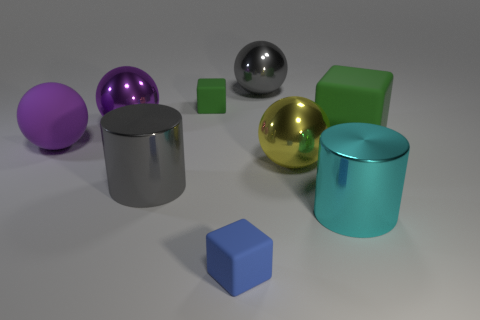The metal ball that is the same color as the rubber ball is what size?
Make the answer very short. Large. Does the large rubber object that is on the right side of the gray sphere have the same color as the tiny rubber block behind the gray metal cylinder?
Your response must be concise. Yes. There is a big thing that is the same color as the big matte ball; what shape is it?
Provide a succinct answer. Sphere. Is there any other thing that is the same color as the large rubber block?
Offer a terse response. Yes. There is a cube in front of the big rubber cube; what color is it?
Offer a very short reply. Blue. There is a gray cylinder that is in front of the big purple rubber thing; is its size the same as the gray metallic object behind the big purple shiny ball?
Ensure brevity in your answer.  Yes. Is there a yellow metal sphere of the same size as the purple matte ball?
Provide a short and direct response. Yes. There is a small matte object behind the large rubber cube; how many big gray metal things are in front of it?
Offer a terse response. 1. What material is the tiny green block?
Your answer should be compact. Rubber. There is a large cyan cylinder; how many cyan cylinders are on the left side of it?
Your answer should be very brief. 0. 